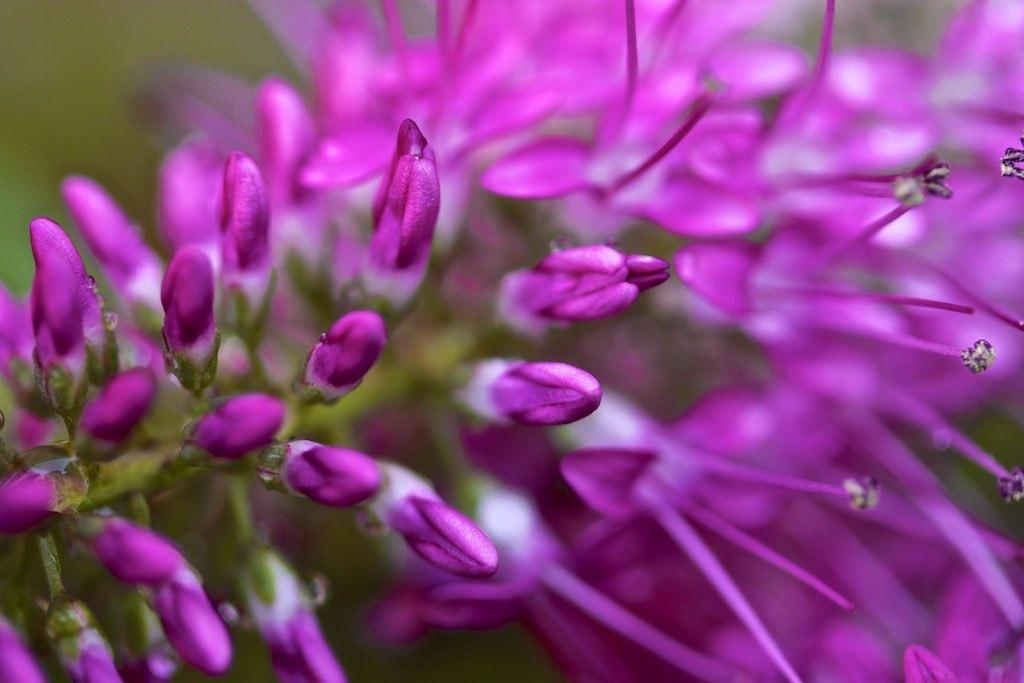What type of plants can be seen in the image? There are flowers in the image. Are there any unopened flowers in the image? Yes, there are buds in the image. How would you describe the background of the image? The background of the image is blurred. Can you tell me how many balloons are floating in the background of the image? There are no balloons present in the image; it features flowers and buds with a blurred background. What type of game is being played in the image? There is no game being played in the image; it features flowers and buds with a blurred background. 